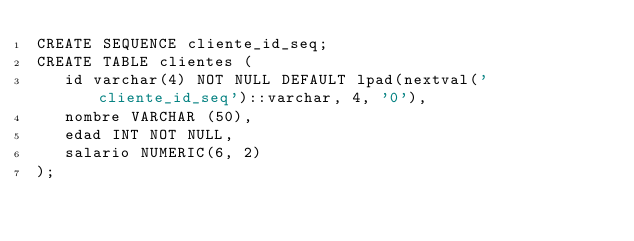<code> <loc_0><loc_0><loc_500><loc_500><_SQL_>CREATE SEQUENCE cliente_id_seq;
CREATE TABLE clientes (
   id varchar(4) NOT NULL DEFAULT lpad(nextval('cliente_id_seq')::varchar, 4, '0'),
   nombre VARCHAR (50),
   edad INT NOT NULL,
   salario NUMERIC(6, 2)
);

</code> 